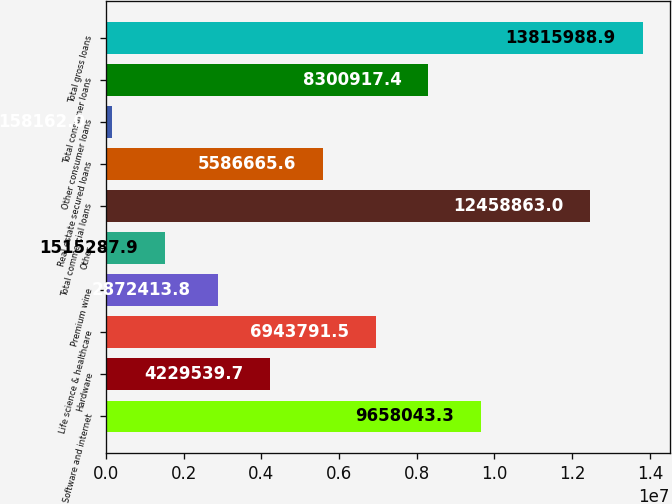<chart> <loc_0><loc_0><loc_500><loc_500><bar_chart><fcel>Software and internet<fcel>Hardware<fcel>Life science & healthcare<fcel>Premium wine<fcel>Other<fcel>Total commercial loans<fcel>Real estate secured loans<fcel>Other consumer loans<fcel>Total consumer loans<fcel>Total gross loans<nl><fcel>9.65804e+06<fcel>4.22954e+06<fcel>6.94379e+06<fcel>2.87241e+06<fcel>1.51529e+06<fcel>1.24589e+07<fcel>5.58667e+06<fcel>158162<fcel>8.30092e+06<fcel>1.3816e+07<nl></chart> 